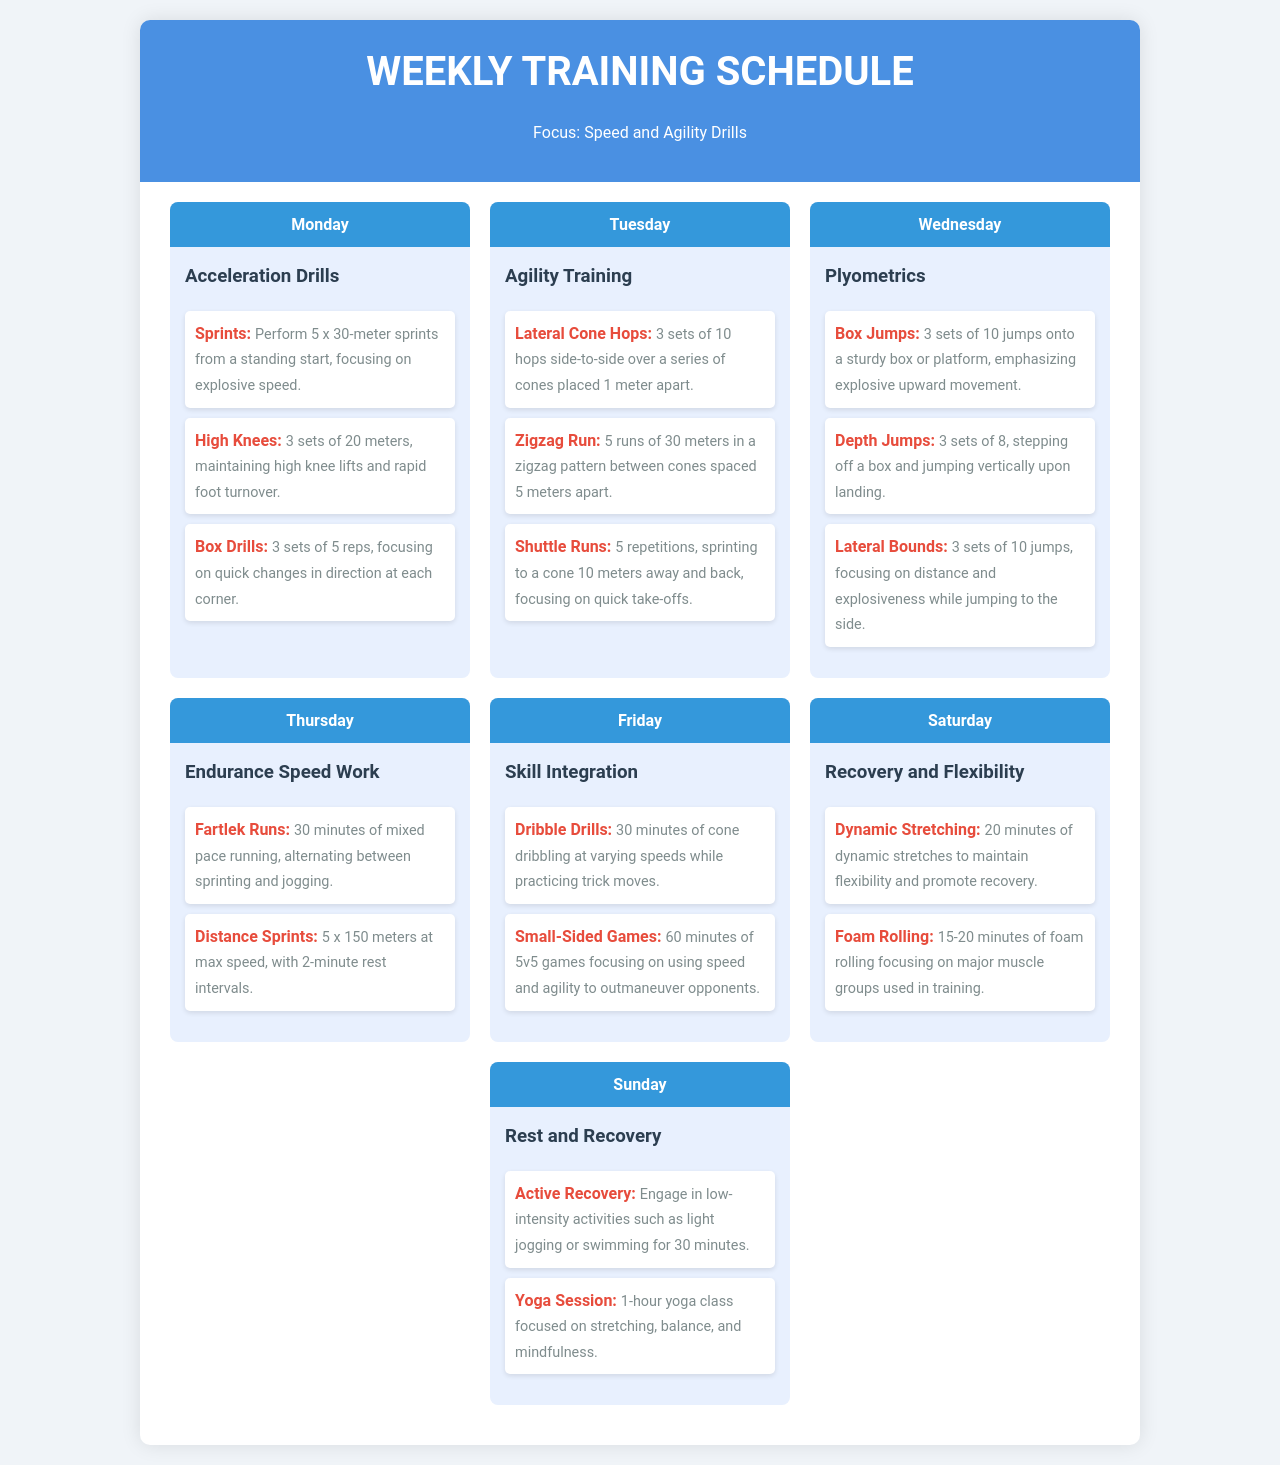What is the focus of the weekly training schedule? The focus of the schedule is specified at the top of the document.
Answer: Speed and Agility Drills How many sets are performed for box jumps on Wednesday? The number of sets is mentioned in the description of the box jumps exercise for Wednesday.
Answer: 3 sets What type of training is scheduled for Tuesday? The type of training for Tuesday is stated in the header of that day's section.
Answer: Agility Training What is the duration of the Fartlek runs on Thursday? The duration for Fartlek runs is detailed in its description under Thursday.
Answer: 30 minutes Which exercise involves light jogging or swimming? This exercise is specified in the Sunday section regarding active recovery.
Answer: Active Recovery How many repetitions are included in the shuttle runs? The number of repetitions for shuttle runs is indicated in the Tuesday section.
Answer: 5 repetitions What kind of yoga class is mentioned for Sunday? The type of yoga class is elaborated in the Sunday section description.
Answer: Yoga Session Which day includes endurance speed work? The day that includes this type of work is noted in the header for that day's section.
Answer: Thursday How long is the foam rolling session on Saturday? The duration of the foam rolling session is provided in that day's content.
Answer: 15-20 minutes 